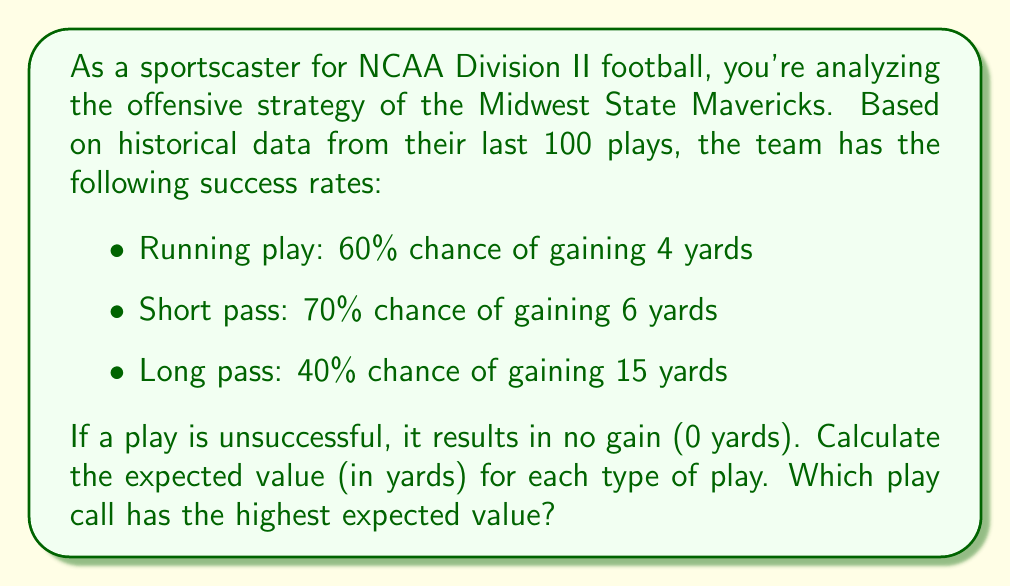Teach me how to tackle this problem. To solve this problem, we need to calculate the expected value for each type of play using the given probabilities and yardage gains. The expected value is calculated by multiplying the probability of success by the yardage gain for a successful play, plus the probability of failure multiplied by zero (since unsuccessful plays result in no gain).

1. Running play:
   $$ EV_{run} = (0.60 \times 4) + (0.40 \times 0) = 2.4 \text{ yards} $$

2. Short pass:
   $$ EV_{short} = (0.70 \times 6) + (0.30 \times 0) = 4.2 \text{ yards} $$

3. Long pass:
   $$ EV_{long} = (0.40 \times 15) + (0.60 \times 0) = 6.0 \text{ yards} $$

To determine which play call has the highest expected value, we compare the results:

$$ EV_{long} > EV_{short} > EV_{run} $$
$$ 6.0 > 4.2 > 2.4 $$

Therefore, the long pass has the highest expected value at 6.0 yards.
Answer: The expected values for each play are:
Running play: 2.4 yards
Short pass: 4.2 yards
Long pass: 6.0 yards

The long pass has the highest expected value at 6.0 yards. 